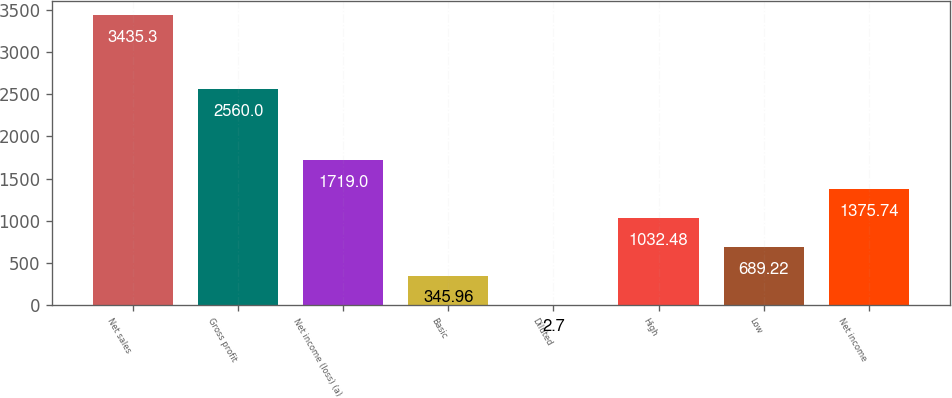<chart> <loc_0><loc_0><loc_500><loc_500><bar_chart><fcel>Net sales<fcel>Gross profit<fcel>Net income (loss) (a)<fcel>Basic<fcel>Diluted<fcel>High<fcel>Low<fcel>Net income<nl><fcel>3435.3<fcel>2560<fcel>1719<fcel>345.96<fcel>2.7<fcel>1032.48<fcel>689.22<fcel>1375.74<nl></chart> 